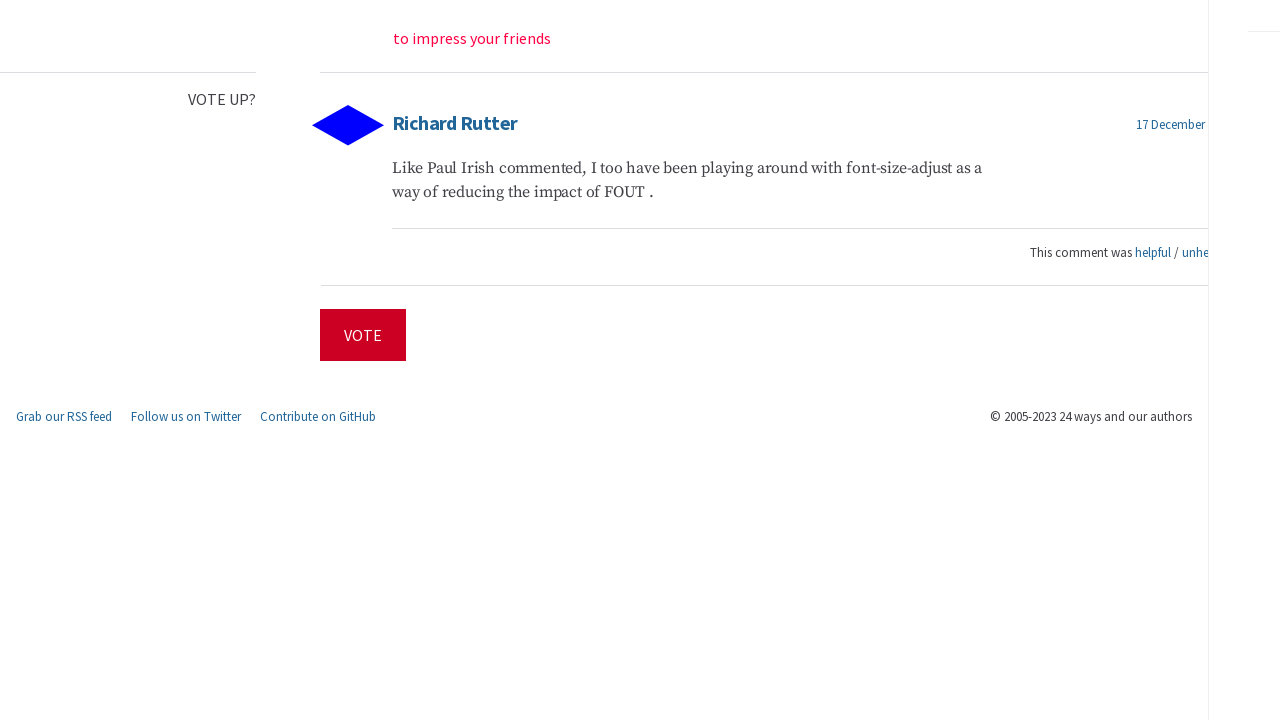Could you guide me through the process of developing this website with HTML? Creating a website like the one shown in your image involves several steps using HTML and other web technologies. First, lay out the basic structure with HTML, defining elements such as header, section, and footer. Use <header> for introducing the site or topic, <section> for main content like articles and comments, and <footer> for additional information like copyright and social media links. Style the page with CSS for formatting and animations. Finally, include interactive elements using JavaScript, such as voting functionalities or animated menus. 